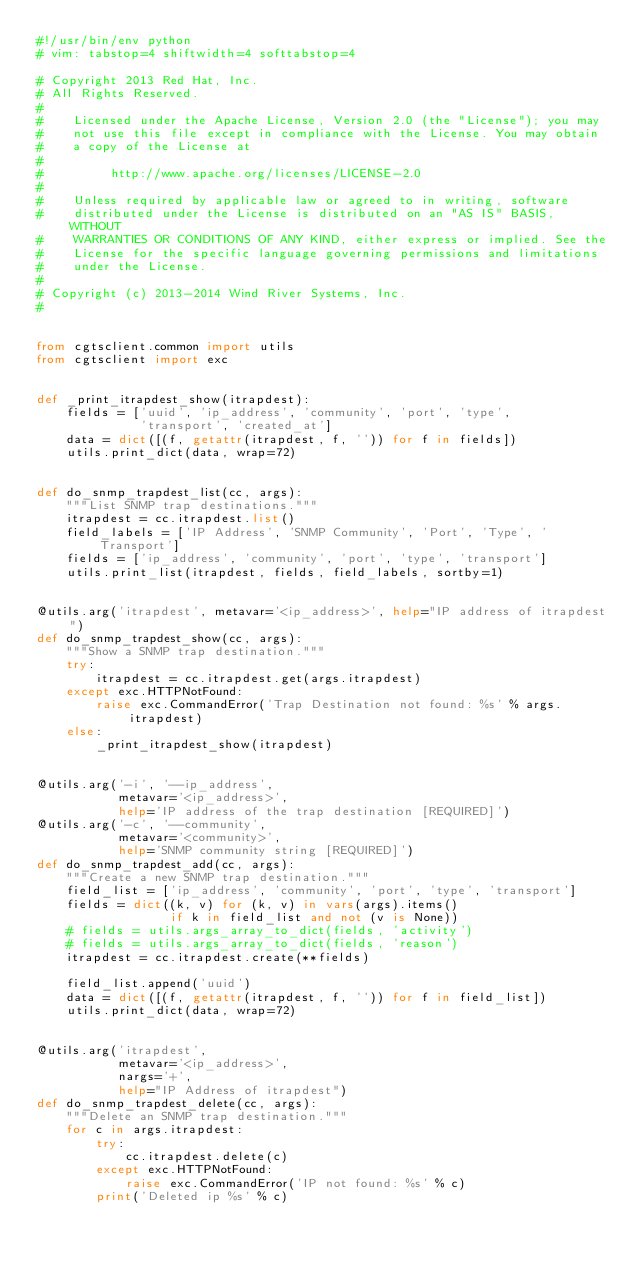<code> <loc_0><loc_0><loc_500><loc_500><_Python_>#!/usr/bin/env python
# vim: tabstop=4 shiftwidth=4 softtabstop=4

# Copyright 2013 Red Hat, Inc.
# All Rights Reserved.
#
#    Licensed under the Apache License, Version 2.0 (the "License"); you may
#    not use this file except in compliance with the License. You may obtain
#    a copy of the License at
#
#         http://www.apache.org/licenses/LICENSE-2.0
#
#    Unless required by applicable law or agreed to in writing, software
#    distributed under the License is distributed on an "AS IS" BASIS, WITHOUT
#    WARRANTIES OR CONDITIONS OF ANY KIND, either express or implied. See the
#    License for the specific language governing permissions and limitations
#    under the License.
#
# Copyright (c) 2013-2014 Wind River Systems, Inc.
#


from cgtsclient.common import utils
from cgtsclient import exc


def _print_itrapdest_show(itrapdest):
    fields = ['uuid', 'ip_address', 'community', 'port', 'type',
              'transport', 'created_at']
    data = dict([(f, getattr(itrapdest, f, '')) for f in fields])
    utils.print_dict(data, wrap=72)


def do_snmp_trapdest_list(cc, args):
    """List SNMP trap destinations."""
    itrapdest = cc.itrapdest.list()
    field_labels = ['IP Address', 'SNMP Community', 'Port', 'Type', 'Transport']
    fields = ['ip_address', 'community', 'port', 'type', 'transport']
    utils.print_list(itrapdest, fields, field_labels, sortby=1)


@utils.arg('itrapdest', metavar='<ip_address>', help="IP address of itrapdest")
def do_snmp_trapdest_show(cc, args):
    """Show a SNMP trap destination."""
    try:
        itrapdest = cc.itrapdest.get(args.itrapdest)
    except exc.HTTPNotFound:
        raise exc.CommandError('Trap Destination not found: %s' % args.itrapdest)
    else:
        _print_itrapdest_show(itrapdest)


@utils.arg('-i', '--ip_address',
           metavar='<ip_address>',
           help='IP address of the trap destination [REQUIRED]')
@utils.arg('-c', '--community',
           metavar='<community>',
           help='SNMP community string [REQUIRED]')
def do_snmp_trapdest_add(cc, args):
    """Create a new SNMP trap destination."""
    field_list = ['ip_address', 'community', 'port', 'type', 'transport']
    fields = dict((k, v) for (k, v) in vars(args).items()
                  if k in field_list and not (v is None))
    # fields = utils.args_array_to_dict(fields, 'activity')
    # fields = utils.args_array_to_dict(fields, 'reason')
    itrapdest = cc.itrapdest.create(**fields)

    field_list.append('uuid')
    data = dict([(f, getattr(itrapdest, f, '')) for f in field_list])
    utils.print_dict(data, wrap=72)


@utils.arg('itrapdest',
           metavar='<ip_address>',
           nargs='+',
           help="IP Address of itrapdest")
def do_snmp_trapdest_delete(cc, args):
    """Delete an SNMP trap destination."""
    for c in args.itrapdest:
        try:
            cc.itrapdest.delete(c)
        except exc.HTTPNotFound:
            raise exc.CommandError('IP not found: %s' % c)
        print('Deleted ip %s' % c)
</code> 